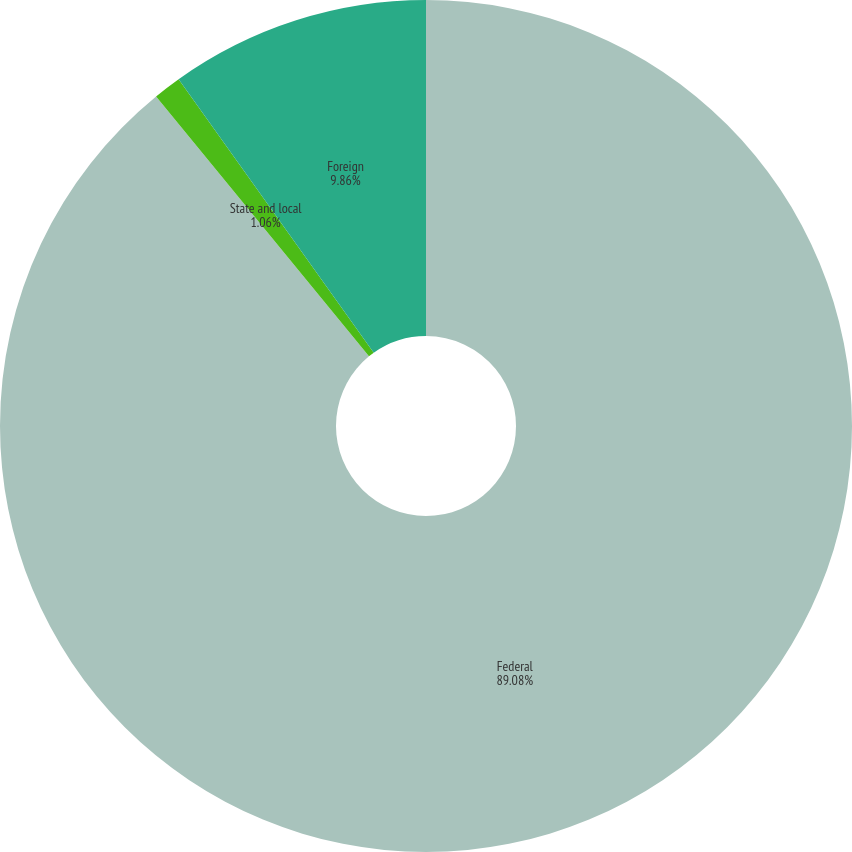<chart> <loc_0><loc_0><loc_500><loc_500><pie_chart><fcel>Federal<fcel>State and local<fcel>Foreign<nl><fcel>89.07%<fcel>1.06%<fcel>9.86%<nl></chart> 